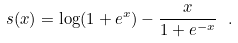<formula> <loc_0><loc_0><loc_500><loc_500>s ( x ) = \log ( 1 + e ^ { x } ) - \frac { x } { 1 + e ^ { - x } } \ .</formula> 